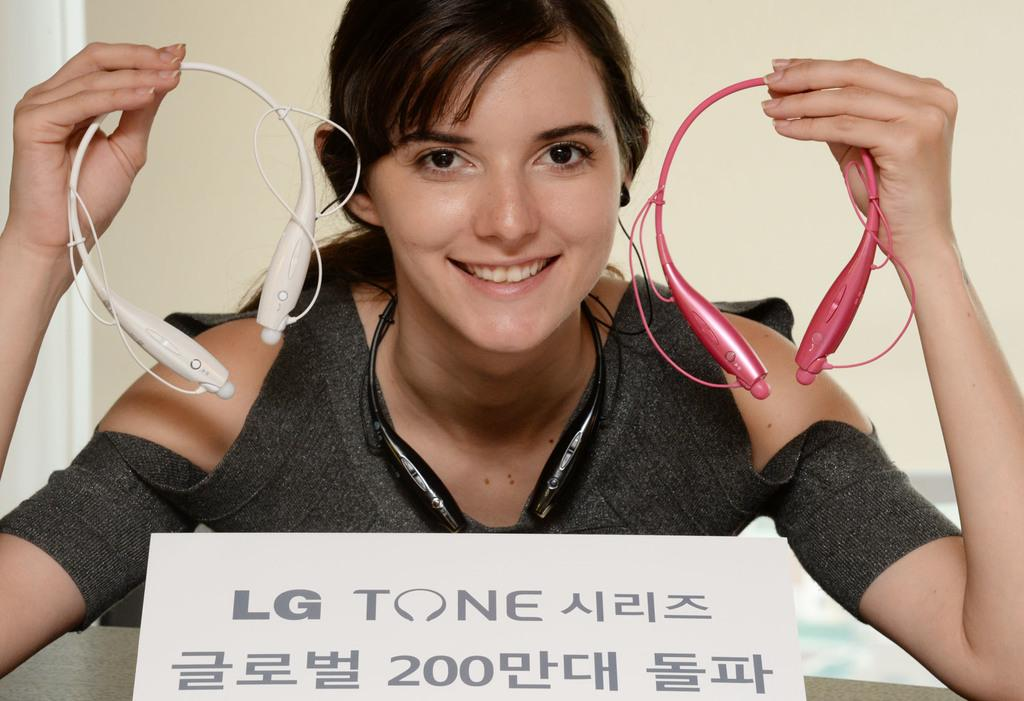Who is the main subject in the image? There is a woman in the image. What is the woman holding in her hands? The woman is holding Bluetooth headsets in her hands. What is the woman's facial expression? The woman is smiling. Can you describe any other objects or signs in the image? There is a name board present in the image. What type of tray is the woman using to hold the wrens in the image? There is no tray or wrens present in the image. 